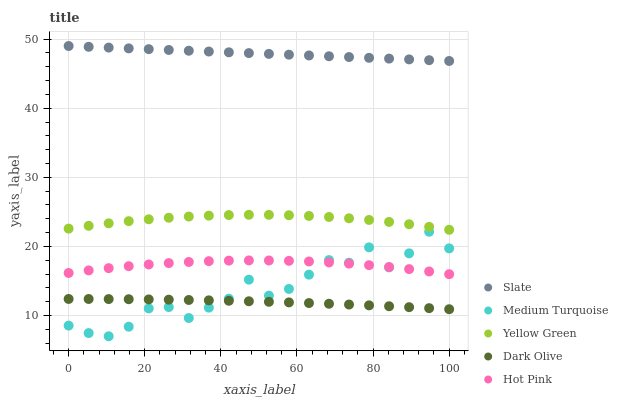Does Dark Olive have the minimum area under the curve?
Answer yes or no. Yes. Does Slate have the maximum area under the curve?
Answer yes or no. Yes. Does Yellow Green have the minimum area under the curve?
Answer yes or no. No. Does Yellow Green have the maximum area under the curve?
Answer yes or no. No. Is Slate the smoothest?
Answer yes or no. Yes. Is Medium Turquoise the roughest?
Answer yes or no. Yes. Is Dark Olive the smoothest?
Answer yes or no. No. Is Dark Olive the roughest?
Answer yes or no. No. Does Medium Turquoise have the lowest value?
Answer yes or no. Yes. Does Dark Olive have the lowest value?
Answer yes or no. No. Does Slate have the highest value?
Answer yes or no. Yes. Does Yellow Green have the highest value?
Answer yes or no. No. Is Medium Turquoise less than Slate?
Answer yes or no. Yes. Is Yellow Green greater than Dark Olive?
Answer yes or no. Yes. Does Hot Pink intersect Medium Turquoise?
Answer yes or no. Yes. Is Hot Pink less than Medium Turquoise?
Answer yes or no. No. Is Hot Pink greater than Medium Turquoise?
Answer yes or no. No. Does Medium Turquoise intersect Slate?
Answer yes or no. No. 